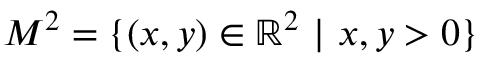<formula> <loc_0><loc_0><loc_500><loc_500>M ^ { 2 } = \{ ( x , y ) \in \mathbb { R } ^ { 2 } \ | \ x , y > 0 \}</formula> 